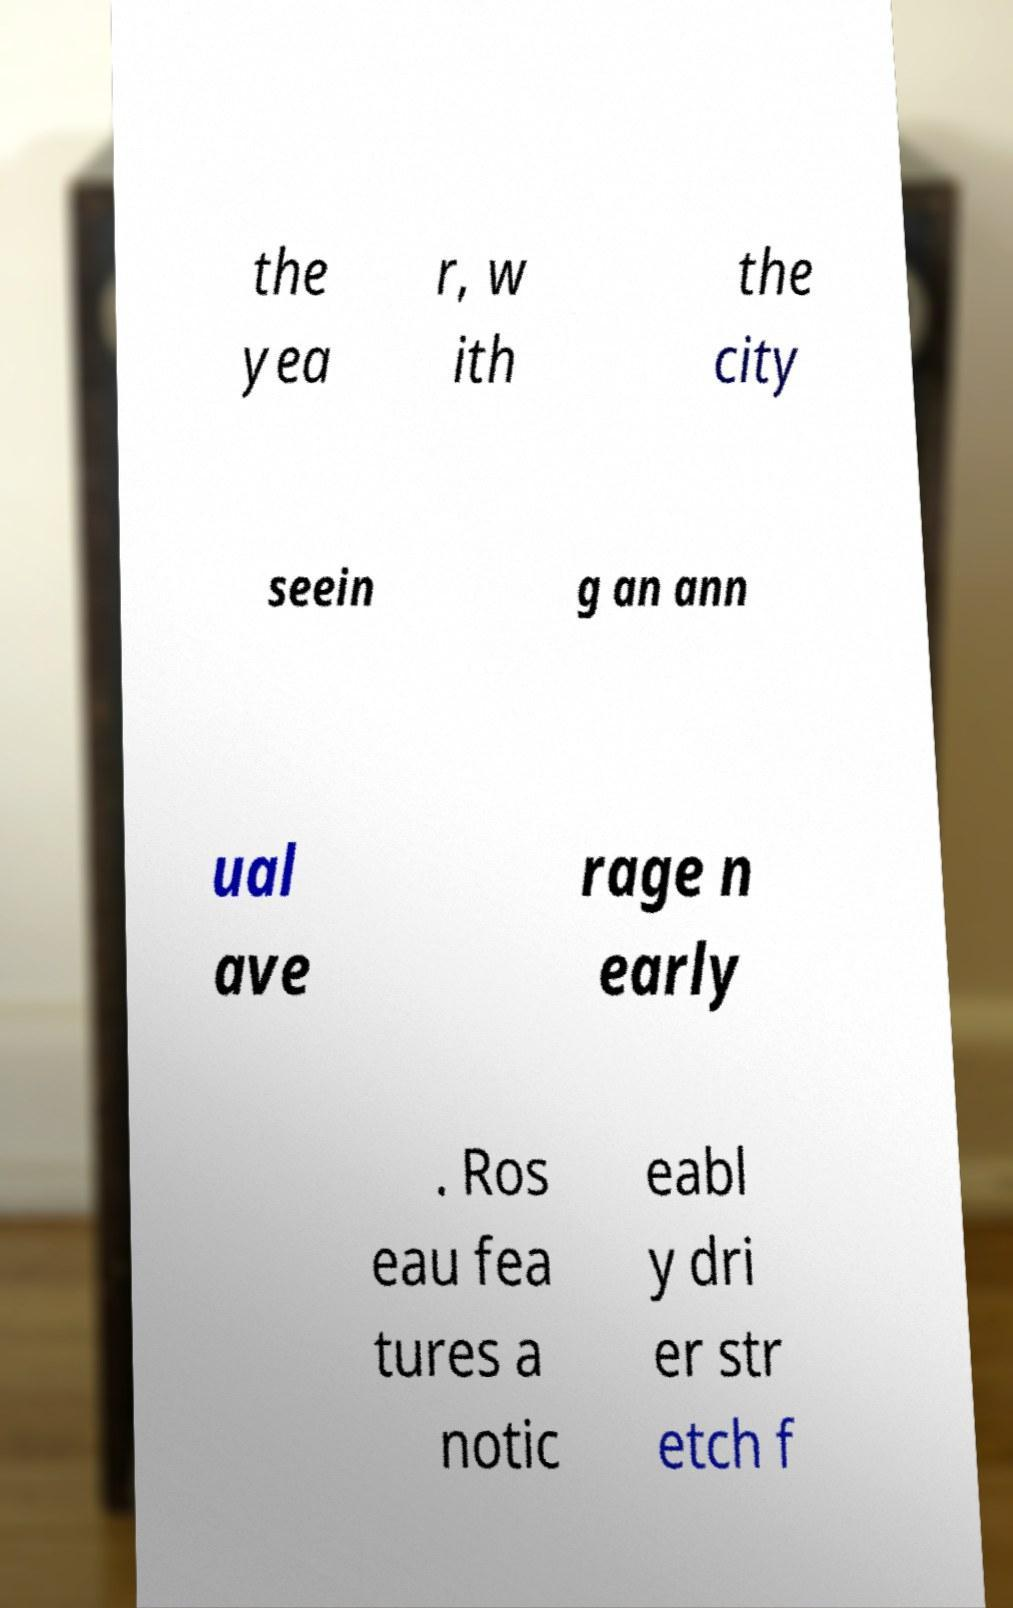Can you accurately transcribe the text from the provided image for me? the yea r, w ith the city seein g an ann ual ave rage n early . Ros eau fea tures a notic eabl y dri er str etch f 